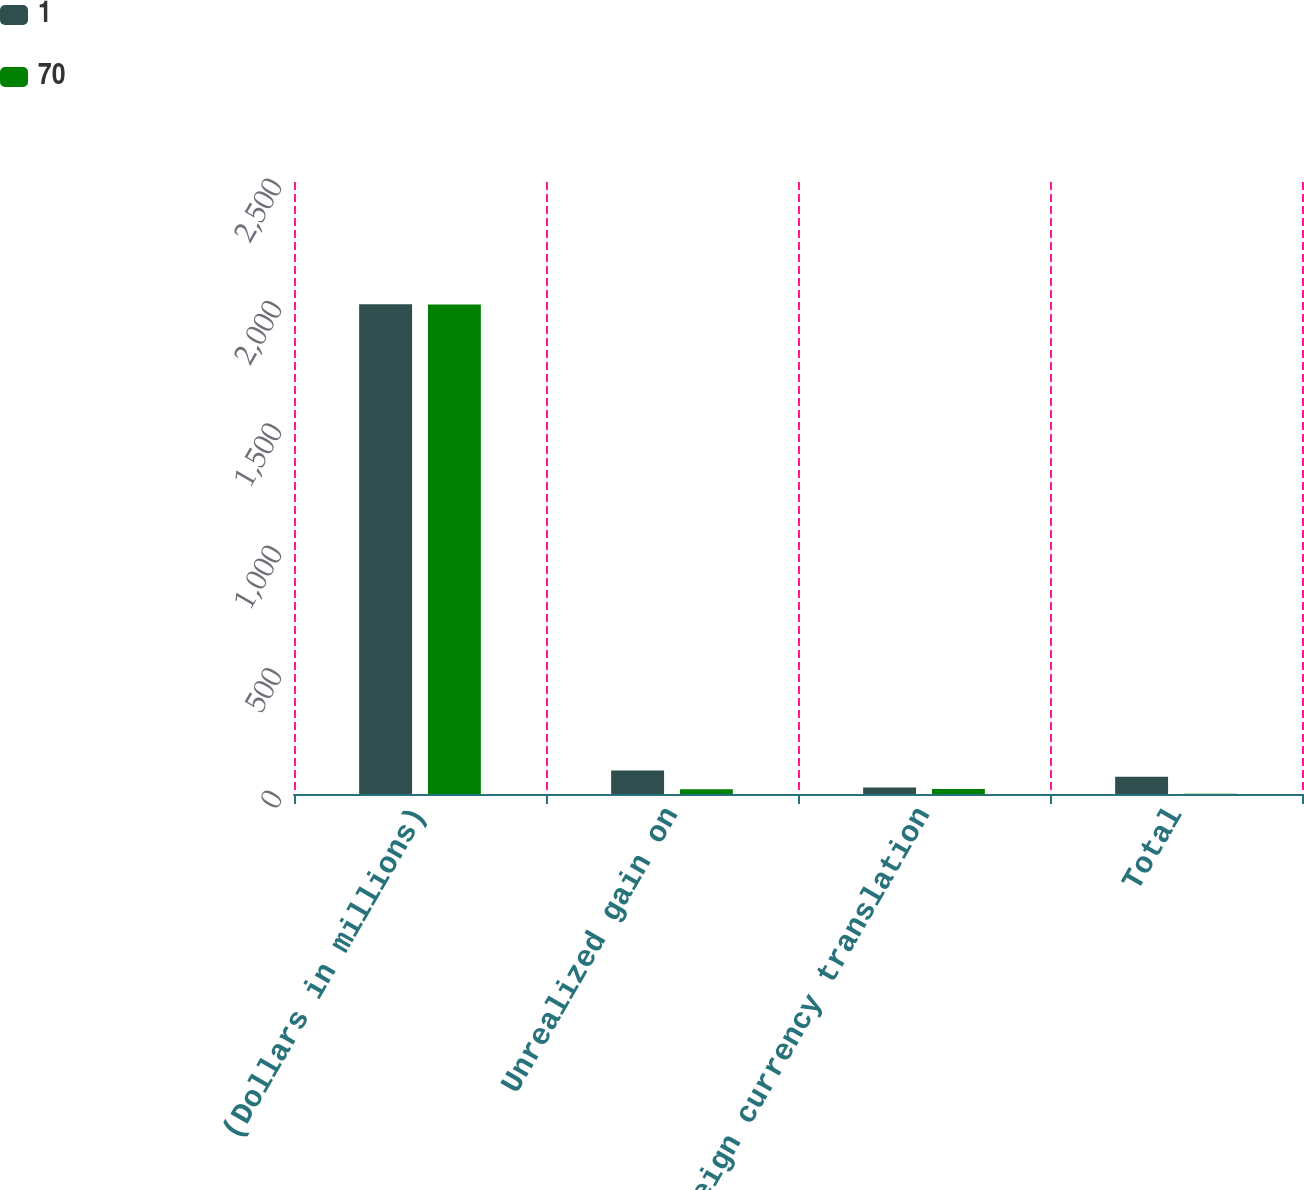<chart> <loc_0><loc_0><loc_500><loc_500><stacked_bar_chart><ecel><fcel>(Dollars in millions)<fcel>Unrealized gain on<fcel>Foreign currency translation<fcel>Total<nl><fcel>1<fcel>2001<fcel>96<fcel>27<fcel>70<nl><fcel>70<fcel>2000<fcel>19<fcel>20<fcel>1<nl></chart> 